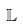Convert formula to latex. <formula><loc_0><loc_0><loc_500><loc_500>\mathbb { L }</formula> 